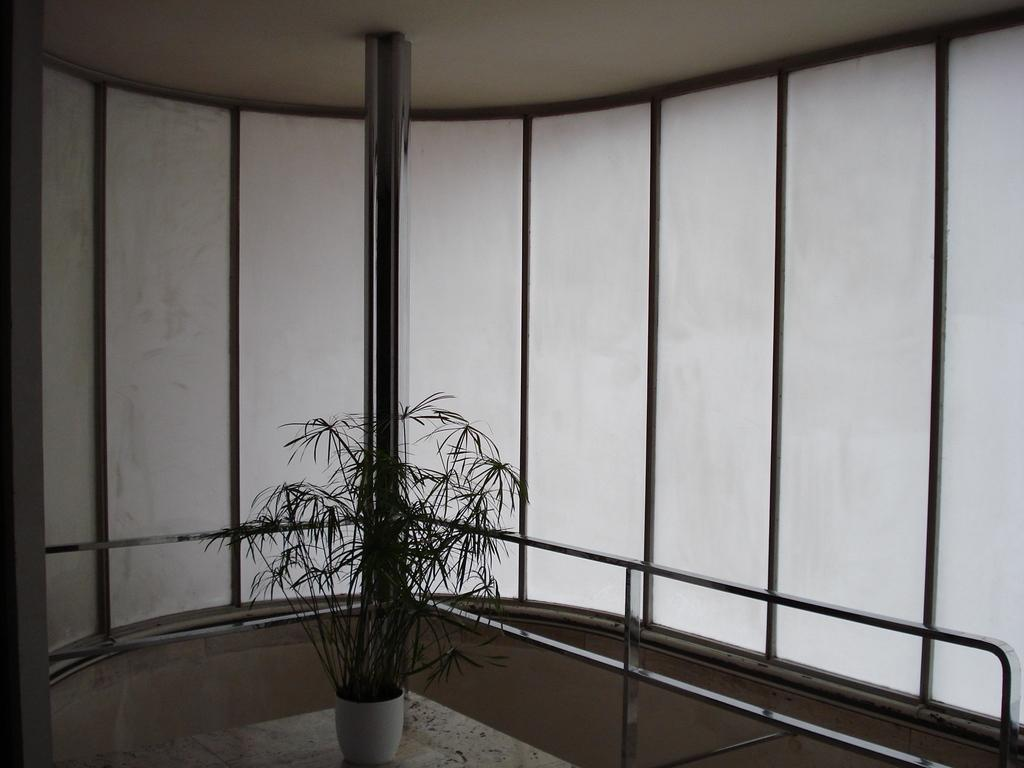What type of plant is in the pot in the image? The facts do not specify the type of plant in the pot. What can be seen at the bottom of the image? There is a railing on the bottom side of the image. What is visible in the background of the image? There is a wall visible in the background of the image. What type of behavior can be observed in the bird in the image? There is no bird present in the image. 